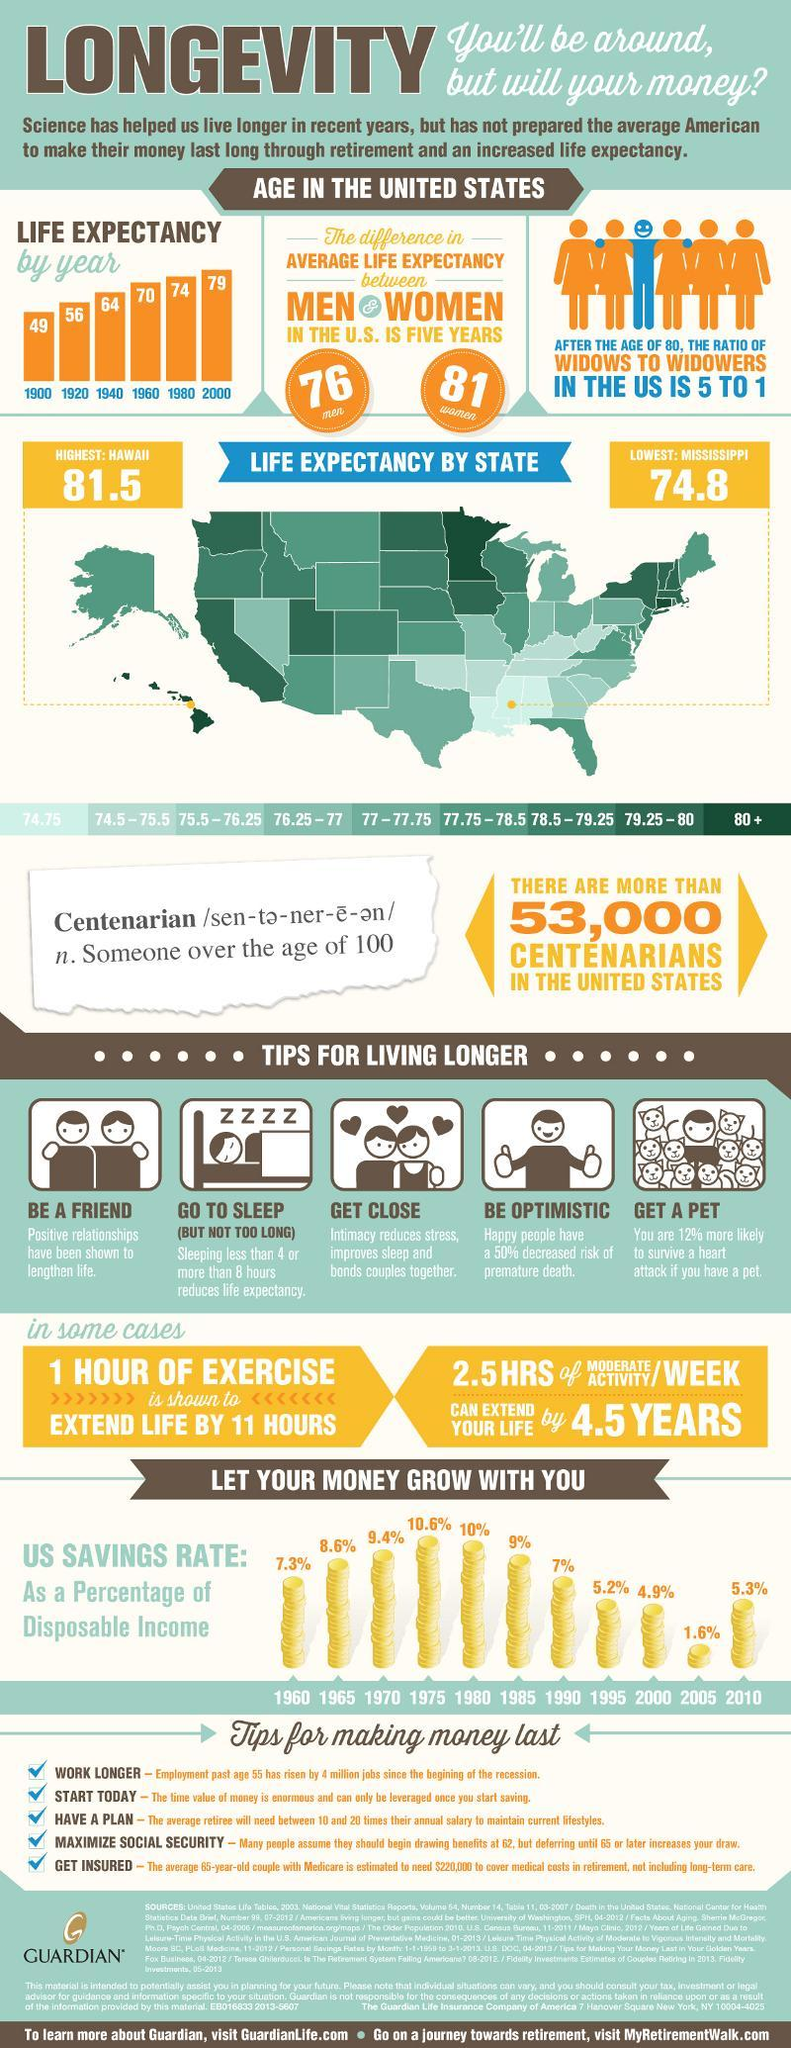Which year has seen the highest life expectancy?
Answer the question with a short phrase. 2000 Around how many people have completed century in the US? 53,000 How many states have lowest life expectancy? 3 Who has higher life expectancy? Women 